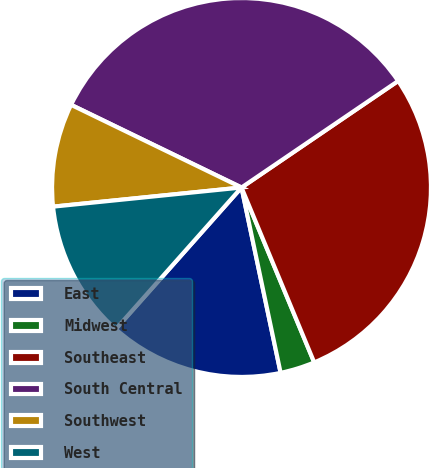Convert chart. <chart><loc_0><loc_0><loc_500><loc_500><pie_chart><fcel>East<fcel>Midwest<fcel>Southeast<fcel>South Central<fcel>Southwest<fcel>West<nl><fcel>14.87%<fcel>2.96%<fcel>28.24%<fcel>33.31%<fcel>8.8%<fcel>11.83%<nl></chart> 